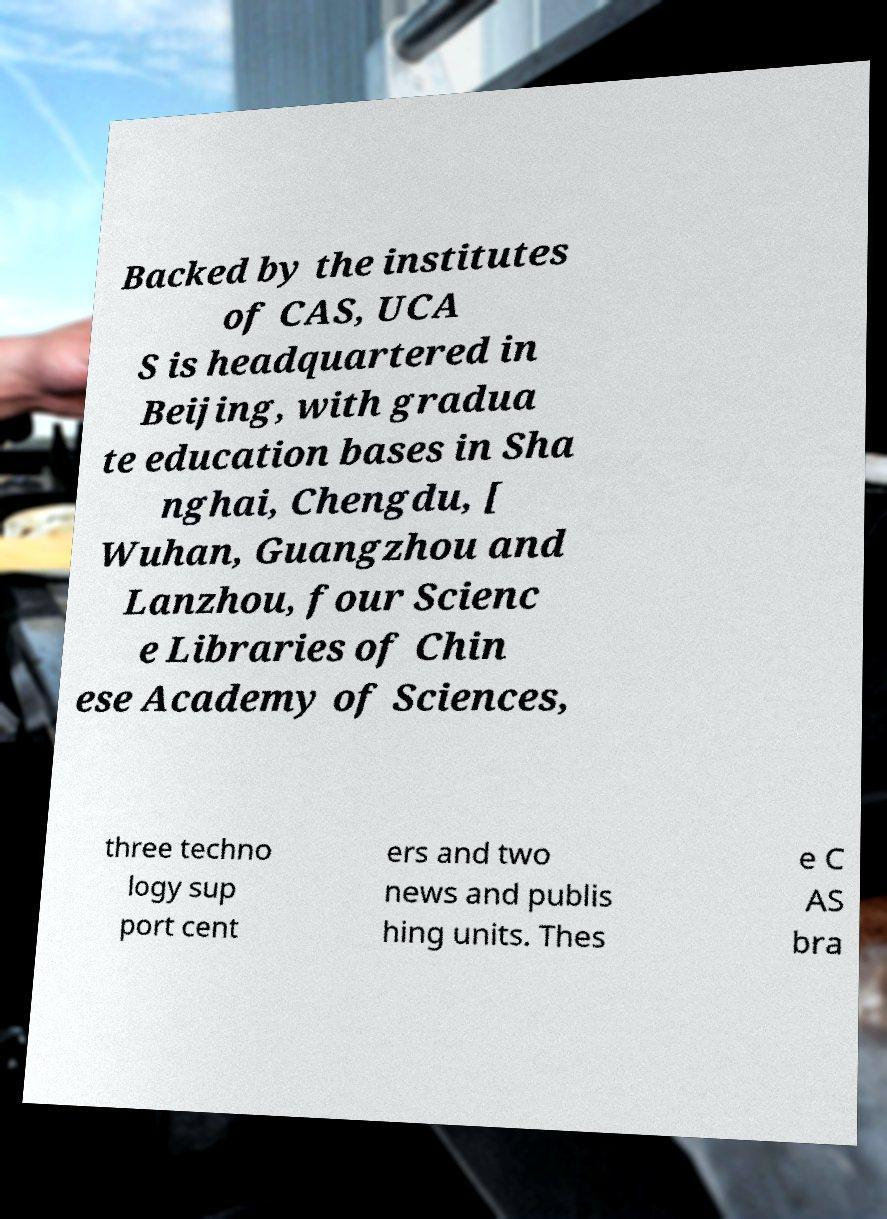Could you assist in decoding the text presented in this image and type it out clearly? Backed by the institutes of CAS, UCA S is headquartered in Beijing, with gradua te education bases in Sha nghai, Chengdu, [ Wuhan, Guangzhou and Lanzhou, four Scienc e Libraries of Chin ese Academy of Sciences, three techno logy sup port cent ers and two news and publis hing units. Thes e C AS bra 